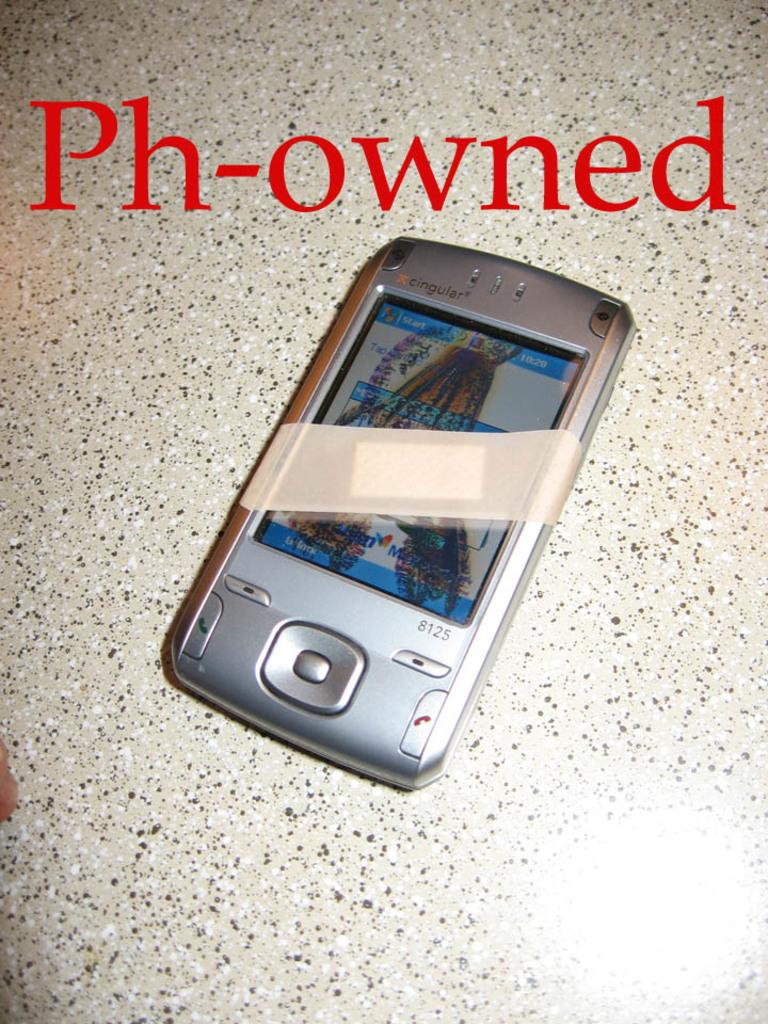What is the writing at the top?
Give a very brief answer. Ph-owned. Does that look like a cingular 8125 phone?
Provide a succinct answer. Yes. 